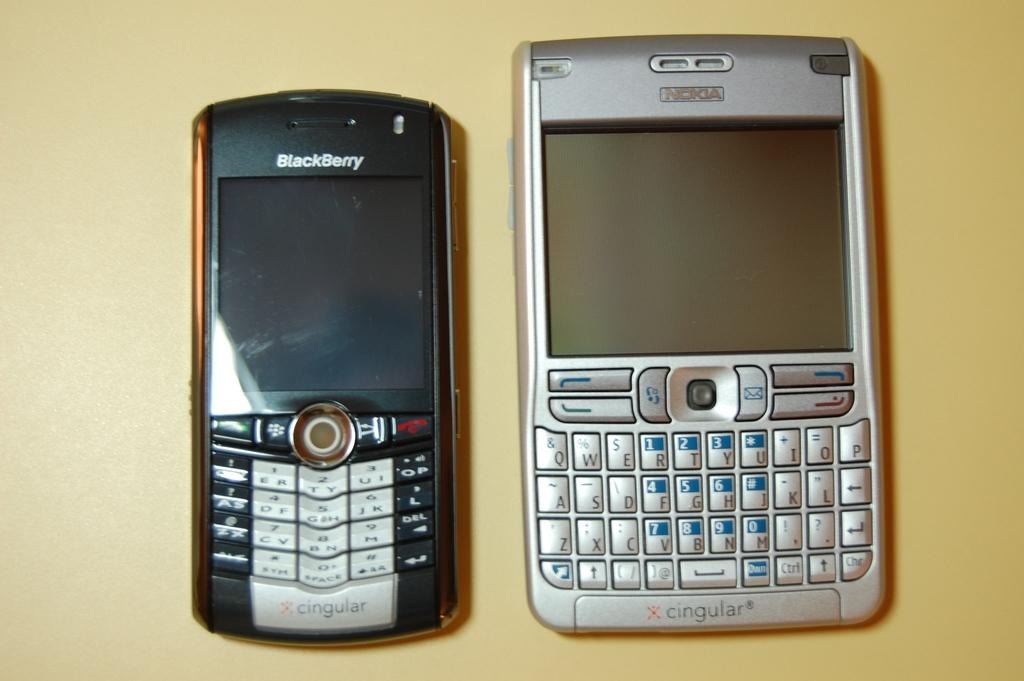Provide a one-sentence caption for the provided image. A smaller Blackberry device sitting next to a larger silver Nokia device. 